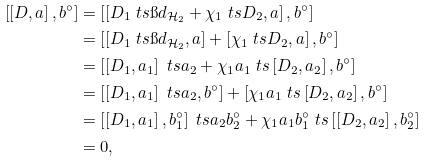Convert formula to latex. <formula><loc_0><loc_0><loc_500><loc_500>\left [ \left [ D , a \right ] , b ^ { \circ } \right ] & = \left [ \left [ D _ { 1 } \ t s \i d _ { \mathcal { H } _ { 2 } } + \chi _ { 1 } \ t s D _ { 2 } , a \right ] , b ^ { \circ } \right ] \\ & = \left [ \left [ D _ { 1 } \ t s \i d _ { \mathcal { H } _ { 2 } } , a \right ] + \left [ \chi _ { 1 } \ t s D _ { 2 } , a \right ] , b ^ { \circ } \right ] \\ & = \left [ \left [ D _ { 1 } , a _ { 1 } \right ] \ t s a _ { 2 } + \chi _ { 1 } a _ { 1 } \ t s \left [ D _ { 2 } , a _ { 2 } \right ] , b ^ { \circ } \right ] \\ & = \left [ \left [ D _ { 1 } , a _ { 1 } \right ] \ t s a _ { 2 } , b ^ { \circ } \right ] + \left [ \chi _ { 1 } a _ { 1 } \ t s \left [ D _ { 2 } , a _ { 2 } \right ] , b ^ { \circ } \right ] \\ & = \left [ \left [ D _ { 1 } , a _ { 1 } \right ] , b _ { 1 } ^ { \circ } \right ] \ t s a _ { 2 } b _ { 2 } ^ { \circ } + \chi _ { 1 } a _ { 1 } b _ { 1 } ^ { \circ } \ t s \left [ \left [ D _ { 2 } , a _ { 2 } \right ] , b _ { 2 } ^ { \circ } \right ] \\ & = 0 ,</formula> 